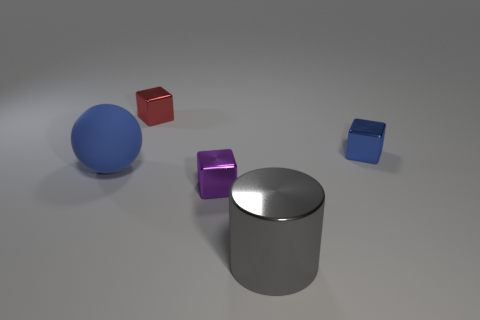Subtract all blue cubes. How many cubes are left? 2 Add 1 cyan objects. How many objects exist? 6 Subtract 1 blocks. How many blocks are left? 2 Subtract all blocks. How many objects are left? 2 Subtract all gray blocks. Subtract all blue cylinders. How many blocks are left? 3 Add 3 blue cubes. How many blue cubes exist? 4 Subtract 0 red balls. How many objects are left? 5 Subtract all matte blocks. Subtract all big cylinders. How many objects are left? 4 Add 4 rubber objects. How many rubber objects are left? 5 